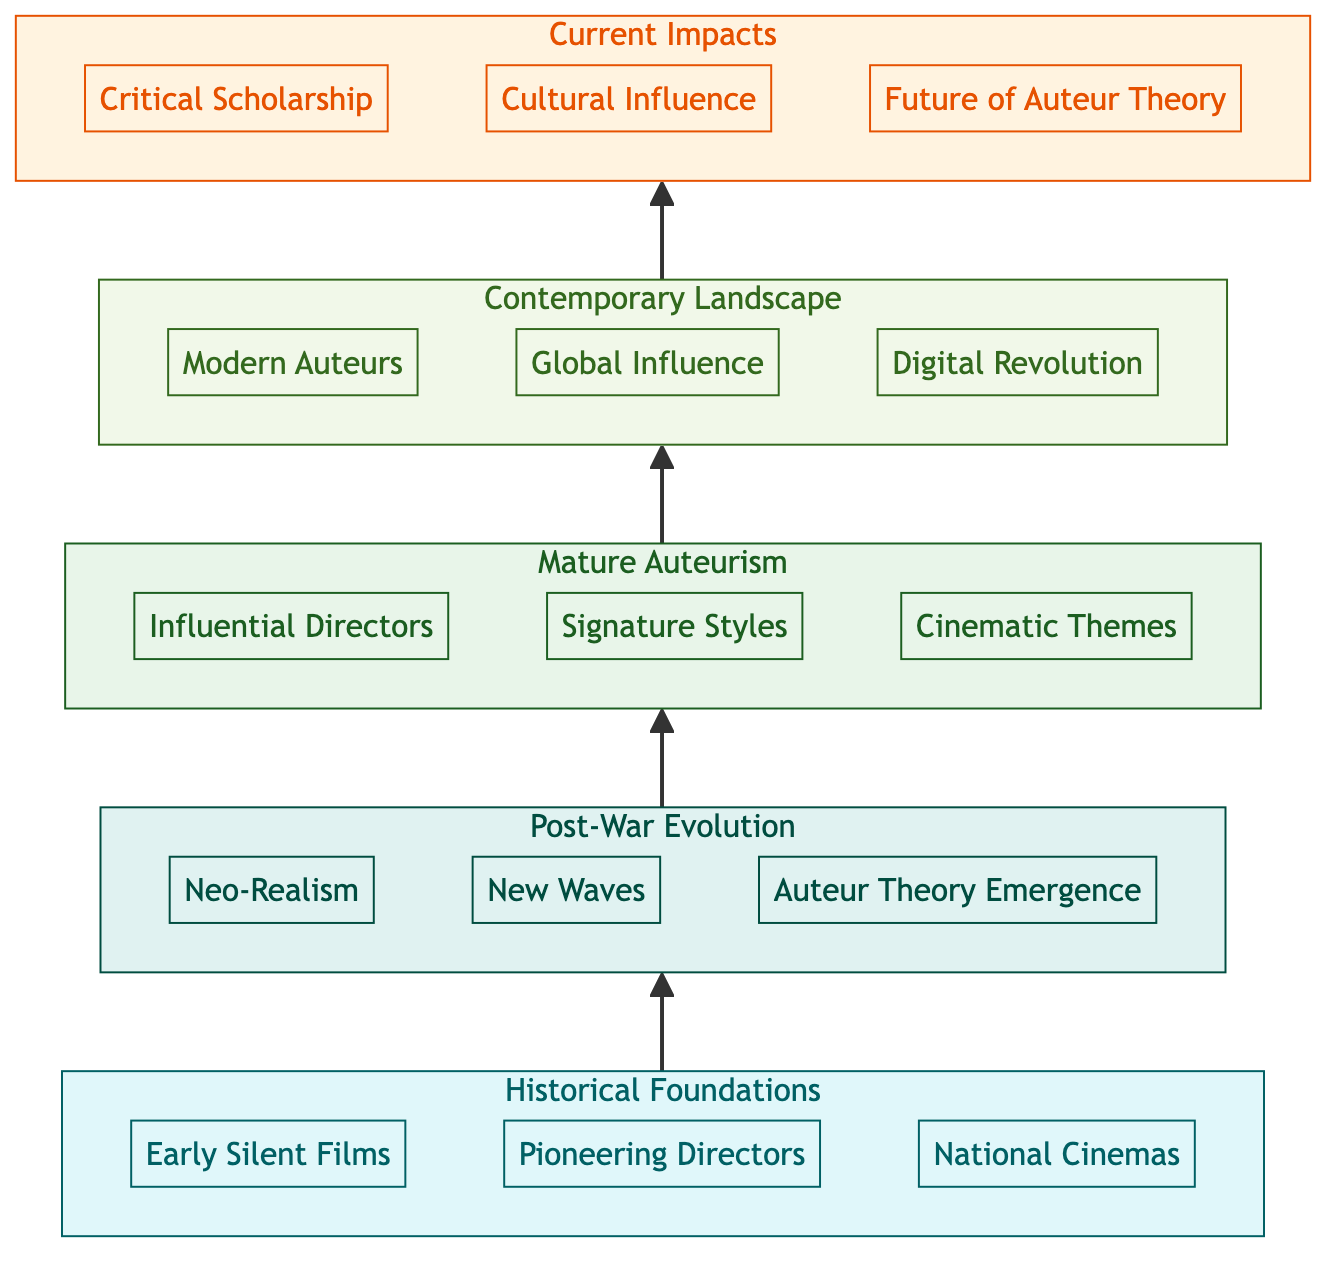What is the title of the highest level in the diagram? The highest level in the diagram is "Current Impacts," which is the fifth level and indicates the contemporary consequences of the auteur theory.
Answer: Current Impacts How many key components are listed under "Post-War Evolution"? In the "Post-War Evolution" level, there are three key components: Neo-Realism, New Waves, and Auteur Theory Emergence.
Answer: 3 Which group of directors is included in the "Mature Auteurism" level? The "Mature Auteurism" level includes influential directors like Federico Fellini and Ingmar Bergman, highlighting key figures in the development of auteur theory in cinema.
Answer: Influential Directors What is the relationship between "Contemporary Landscape" and "Current Impacts"? "Contemporary Landscape" leads to "Current Impacts," indicating a progression from modern cinematic contexts to the effects and implications of auteur theory in today's film study.
Answer: Leads to Which level directly follows "Historical Foundations"? The level directly following "Historical Foundations" is "Post-War Evolution," representing the next chronological phase in the development of auteur theory.
Answer: Post-War Evolution Name a modern auteur mentioned in the “Contemporary Landscape” level. The “Contemporary Landscape” level mentions Pedro Almodóvar as a prominent modern auteur, illustrating current influential figures in European cinema.
Answer: Pedro Almodóvar How many levels are depicted in this flow chart? The flow chart depicts five levels, illustrating the hierarchical structure from historical foundations to current impacts related to auteur theory.
Answer: 5 What is the focus of the new key components in the "Current Impacts" level? The focus of the new key components in the "Current Impacts" level includes critical scholarship, cultural influence, and the future of auteur theory, encompassing both academic and societal aspects.
Answer: Critical Scholarship What example illustrates the intersection of auteur theory and contemporary film platforms? The example illustrating the intersection of auteur theory and contemporary film platforms is "Streaming Platforms," which highlights the impact of technology on film distribution and authorship.
Answer: Streaming Platforms 